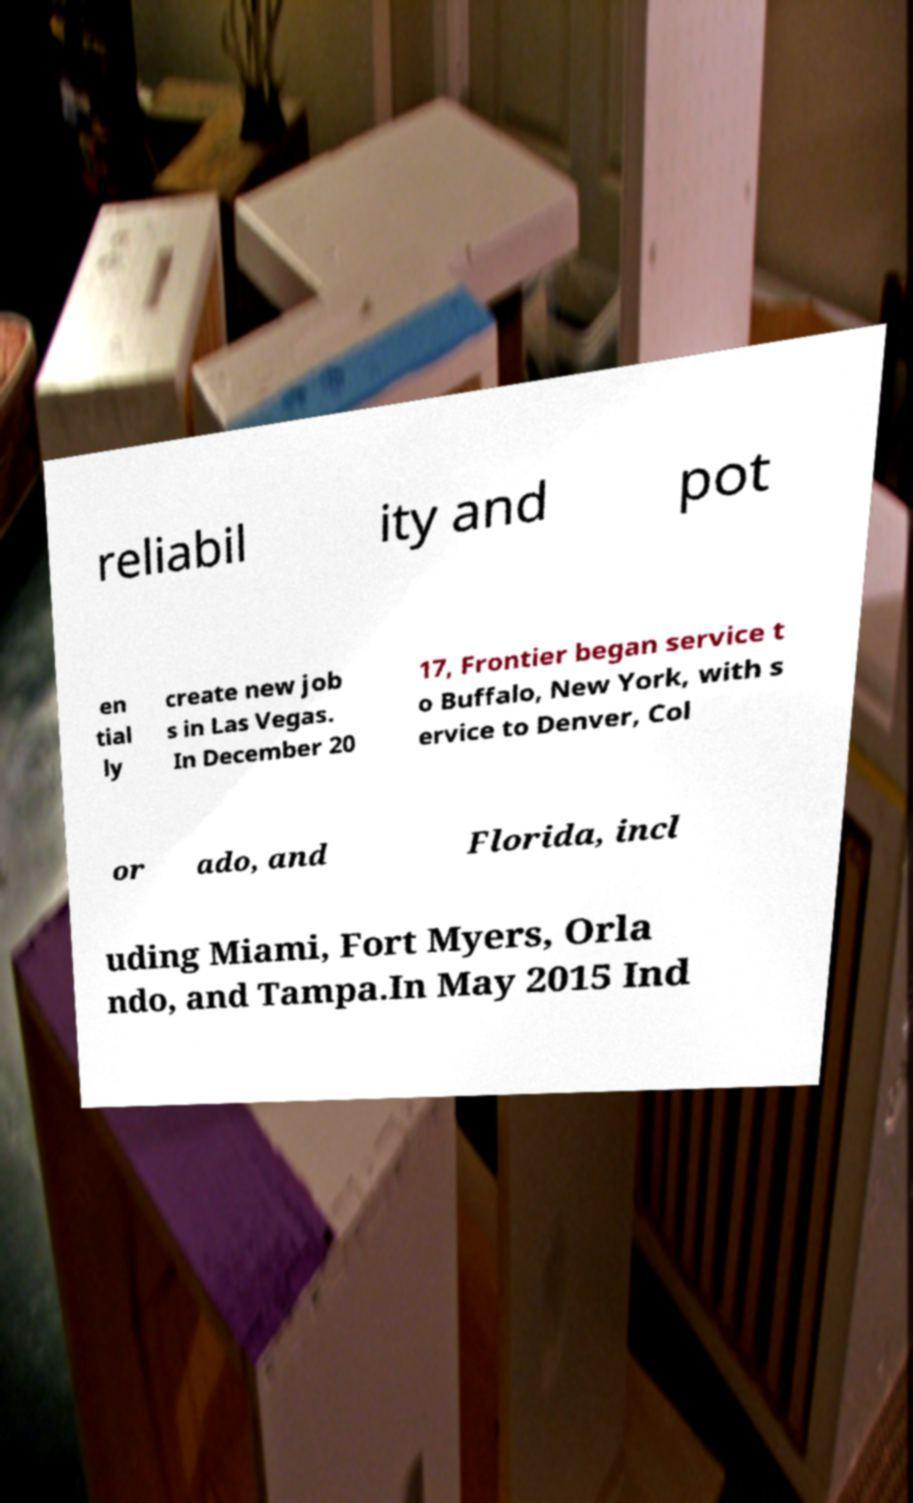For documentation purposes, I need the text within this image transcribed. Could you provide that? reliabil ity and pot en tial ly create new job s in Las Vegas. In December 20 17, Frontier began service t o Buffalo, New York, with s ervice to Denver, Col or ado, and Florida, incl uding Miami, Fort Myers, Orla ndo, and Tampa.In May 2015 Ind 